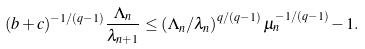<formula> <loc_0><loc_0><loc_500><loc_500>( b + c ) ^ { - 1 / ( q - 1 ) } \frac { \Lambda _ { n } } { \lambda _ { n + 1 } } \leq \left ( \Lambda _ { n } / \lambda _ { n } \right ) ^ { q / ( q - 1 ) } \mu _ { n } ^ { - 1 / ( q - 1 ) } - 1 .</formula> 